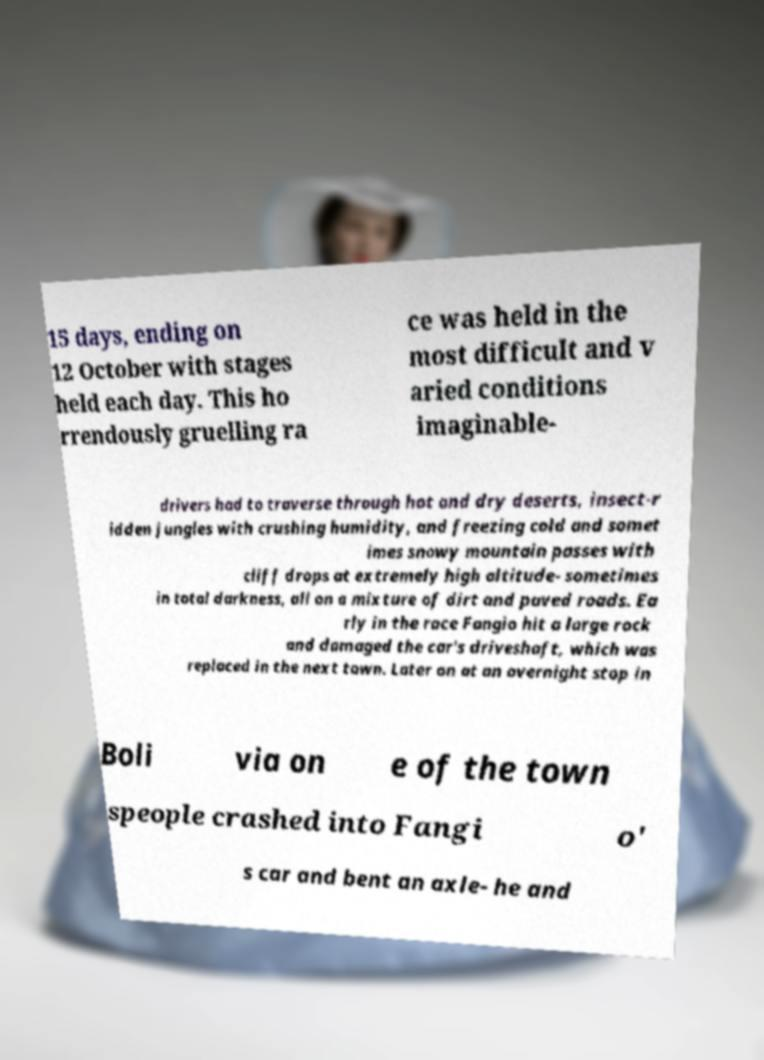Please identify and transcribe the text found in this image. 15 days, ending on 12 October with stages held each day. This ho rrendously gruelling ra ce was held in the most difficult and v aried conditions imaginable- drivers had to traverse through hot and dry deserts, insect-r idden jungles with crushing humidity, and freezing cold and somet imes snowy mountain passes with cliff drops at extremely high altitude- sometimes in total darkness, all on a mixture of dirt and paved roads. Ea rly in the race Fangio hit a large rock and damaged the car's driveshaft, which was replaced in the next town. Later on at an overnight stop in Boli via on e of the town speople crashed into Fangi o' s car and bent an axle- he and 